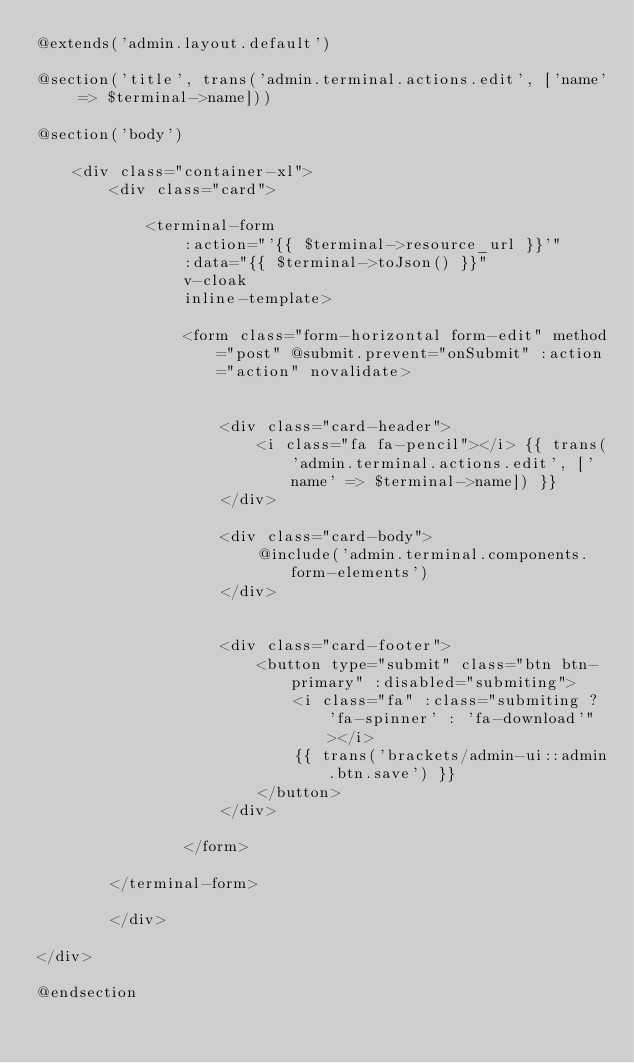Convert code to text. <code><loc_0><loc_0><loc_500><loc_500><_PHP_>@extends('admin.layout.default')

@section('title', trans('admin.terminal.actions.edit', ['name' => $terminal->name]))

@section('body')

    <div class="container-xl">
        <div class="card">

            <terminal-form
                :action="'{{ $terminal->resource_url }}'"
                :data="{{ $terminal->toJson() }}"
                v-cloak
                inline-template>
            
                <form class="form-horizontal form-edit" method="post" @submit.prevent="onSubmit" :action="action" novalidate>


                    <div class="card-header">
                        <i class="fa fa-pencil"></i> {{ trans('admin.terminal.actions.edit', ['name' => $terminal->name]) }}
                    </div>

                    <div class="card-body">
                        @include('admin.terminal.components.form-elements')
                    </div>
                    
                    
                    <div class="card-footer">
                        <button type="submit" class="btn btn-primary" :disabled="submiting">
                            <i class="fa" :class="submiting ? 'fa-spinner' : 'fa-download'"></i>
                            {{ trans('brackets/admin-ui::admin.btn.save') }}
                        </button>
                    </div>
                    
                </form>

        </terminal-form>

        </div>
    
</div>

@endsection</code> 